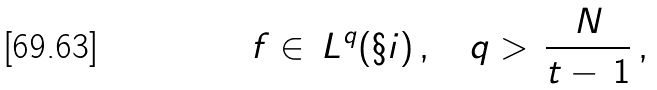Convert formula to latex. <formula><loc_0><loc_0><loc_500><loc_500>\, f \in \, L ^ { q } ( \S i ) \, , \quad q > \, \frac { N } { t - \, 1 } \, ,</formula> 